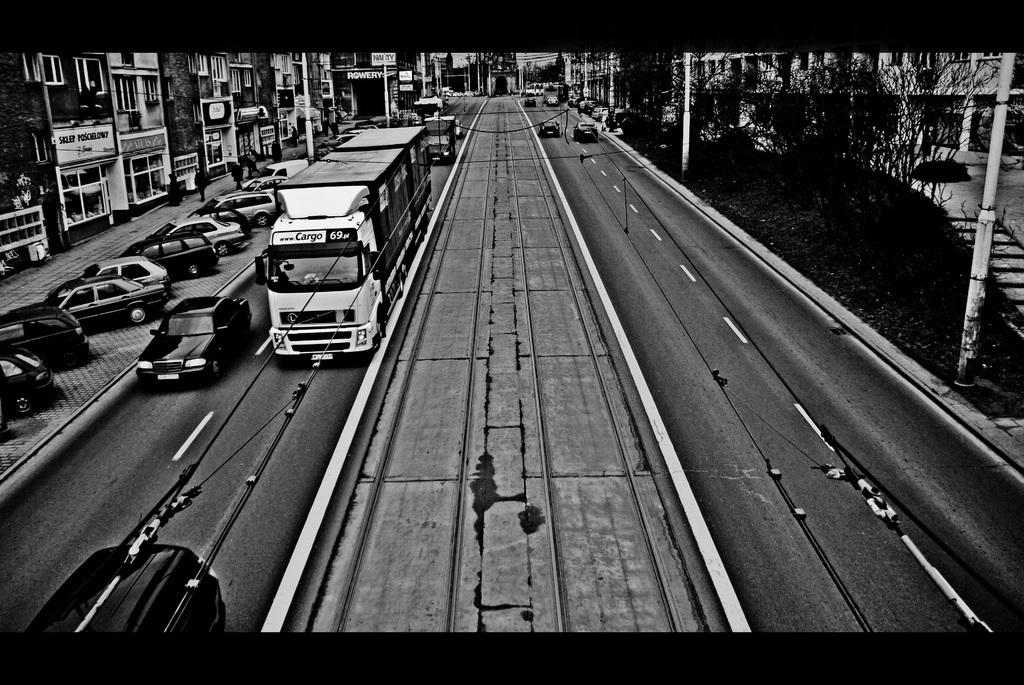What is the color scheme of the image? The image is black and white. What is the main subject of the image? The image depicts a city. What can be seen on the road in the image? Vehicles are traveling on a road, and there is a divider in the middle of the road. Where are the cars parked in the image? Cars are parked in a parking area. What other structures are present in the image? There are multiple buildings and trees in the image. What type of bell can be heard ringing in the image? There is no bell present in the image, and therefore no sound can be heard. How many daughters are visible in the image? There are no people, let alone daughters, present in the image. 